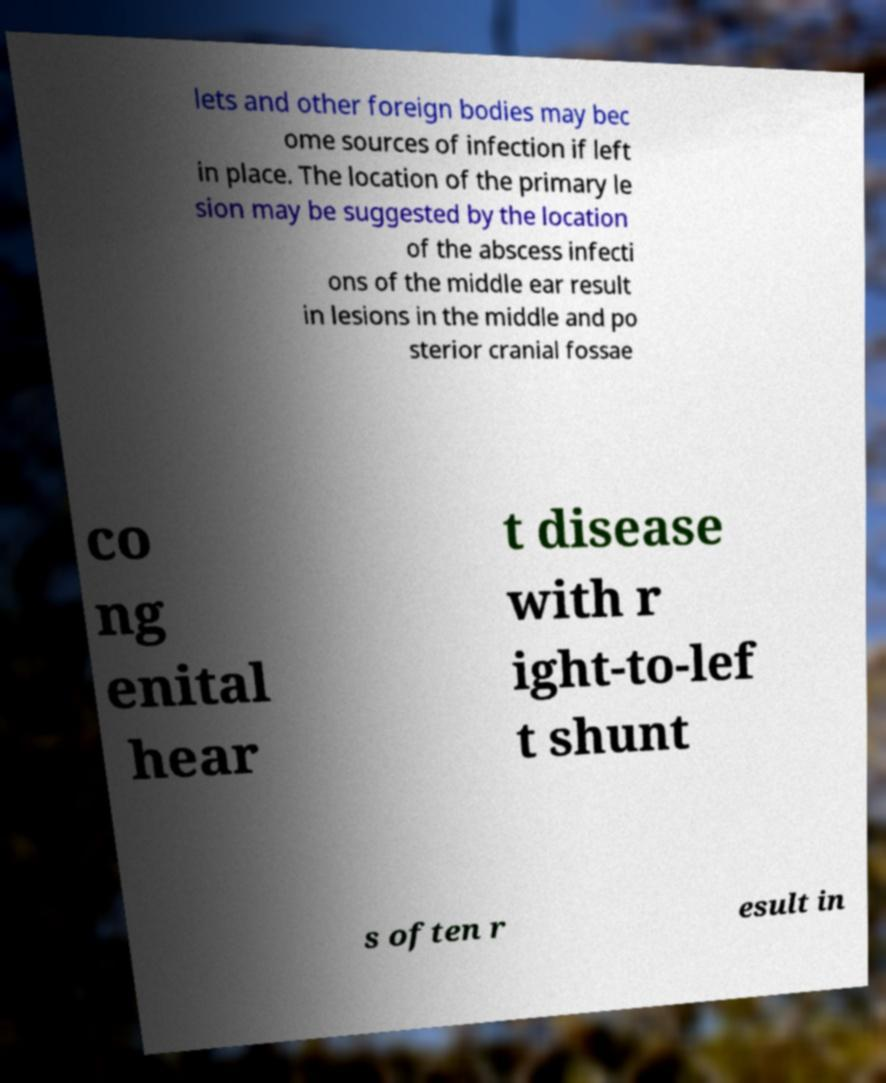I need the written content from this picture converted into text. Can you do that? lets and other foreign bodies may bec ome sources of infection if left in place. The location of the primary le sion may be suggested by the location of the abscess infecti ons of the middle ear result in lesions in the middle and po sterior cranial fossae co ng enital hear t disease with r ight-to-lef t shunt s often r esult in 